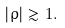Convert formula to latex. <formula><loc_0><loc_0><loc_500><loc_500>| \varrho | \gtrsim 1 .</formula> 